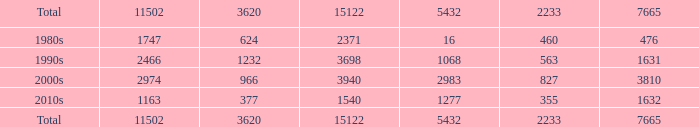Calculate the average of 5432 when it is 11502 greater than 1163, 15122 smaller than 15122, and 3620 lesser than 624. None. 